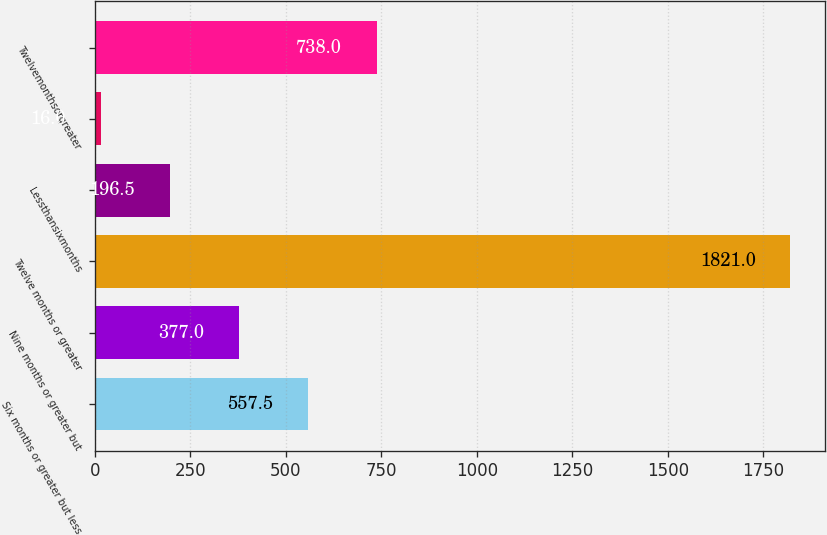Convert chart to OTSL. <chart><loc_0><loc_0><loc_500><loc_500><bar_chart><fcel>Six months or greater but less<fcel>Nine months or greater but<fcel>Twelve months or greater<fcel>Lessthansixmonths<fcel>Unnamed: 4<fcel>Twelvemonthsorgreater<nl><fcel>557.5<fcel>377<fcel>1821<fcel>196.5<fcel>16<fcel>738<nl></chart> 